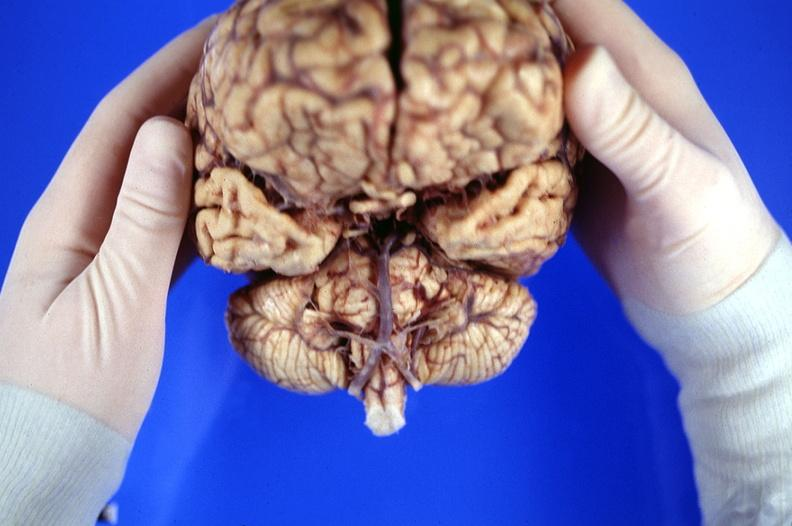what does this image show?
Answer the question using a single word or phrase. Brain 